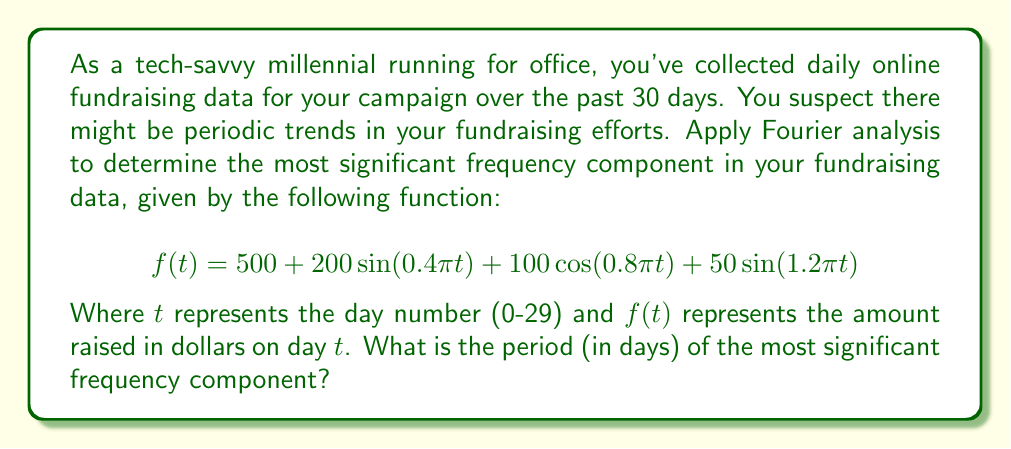What is the answer to this math problem? To solve this problem, we'll follow these steps:

1) First, recall that the Fourier transform helps us decompose a signal into its frequency components. In this case, our signal is already given as a sum of sinusoidal functions.

2) The general form of a sinusoidal function is:

   $$A\sin(2\pi ft) \text{ or } A\cos(2\pi ft)$$

   where $A$ is the amplitude, $f$ is the frequency, and $t$ is time.

3) In our function, we have:

   $$f(t) = 500 + 200\sin(0.4\pi t) + 100\cos(0.8\pi t) + 50\sin(1.2\pi t)$$

4) Let's identify the frequency components:

   - $200\sin(0.4\pi t)$: frequency = $0.4\pi / (2\pi) = 0.2$ cycles/day
   - $100\cos(0.8\pi t)$: frequency = $0.8\pi / (2\pi) = 0.4$ cycles/day
   - $50\sin(1.2\pi t)$: frequency = $1.2\pi / (2\pi) = 0.6$ cycles/day

5) The most significant frequency component is the one with the largest amplitude. Here, it's $200\sin(0.4\pi t)$ with an amplitude of 200.

6) The frequency of this component is 0.2 cycles/day.

7) To find the period, we use the relationship:

   $$\text{Period} = \frac{1}{\text{Frequency}}$$

8) Therefore, the period is:

   $$\text{Period} = \frac{1}{0.2} = 5 \text{ days}$$

Thus, the most significant periodic trend in your fundraising efforts repeats every 5 days.
Answer: 5 days 